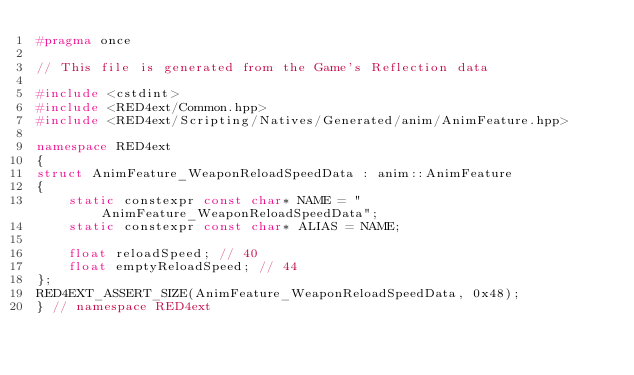Convert code to text. <code><loc_0><loc_0><loc_500><loc_500><_C++_>#pragma once

// This file is generated from the Game's Reflection data

#include <cstdint>
#include <RED4ext/Common.hpp>
#include <RED4ext/Scripting/Natives/Generated/anim/AnimFeature.hpp>

namespace RED4ext
{
struct AnimFeature_WeaponReloadSpeedData : anim::AnimFeature
{
    static constexpr const char* NAME = "AnimFeature_WeaponReloadSpeedData";
    static constexpr const char* ALIAS = NAME;

    float reloadSpeed; // 40
    float emptyReloadSpeed; // 44
};
RED4EXT_ASSERT_SIZE(AnimFeature_WeaponReloadSpeedData, 0x48);
} // namespace RED4ext
</code> 